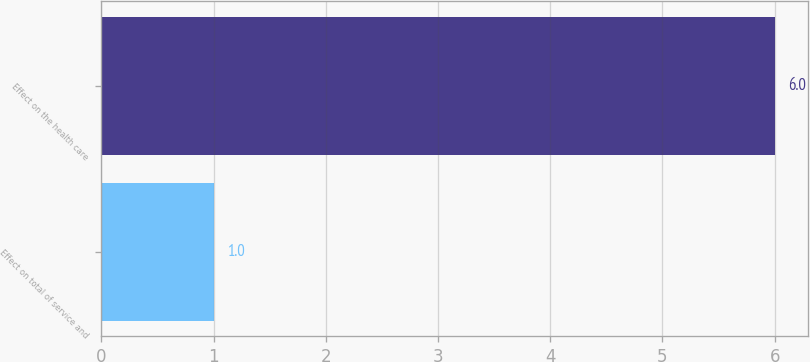<chart> <loc_0><loc_0><loc_500><loc_500><bar_chart><fcel>Effect on total of service and<fcel>Effect on the health care<nl><fcel>1<fcel>6<nl></chart> 